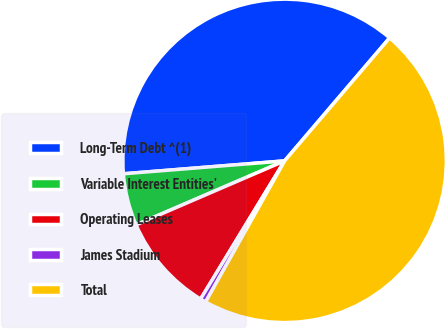Convert chart. <chart><loc_0><loc_0><loc_500><loc_500><pie_chart><fcel>Long-Term Debt ^(1)<fcel>Variable Interest Entities'<fcel>Operating Leases<fcel>James Stadium<fcel>Total<nl><fcel>37.52%<fcel>5.2%<fcel>9.83%<fcel>0.57%<fcel>46.88%<nl></chart> 